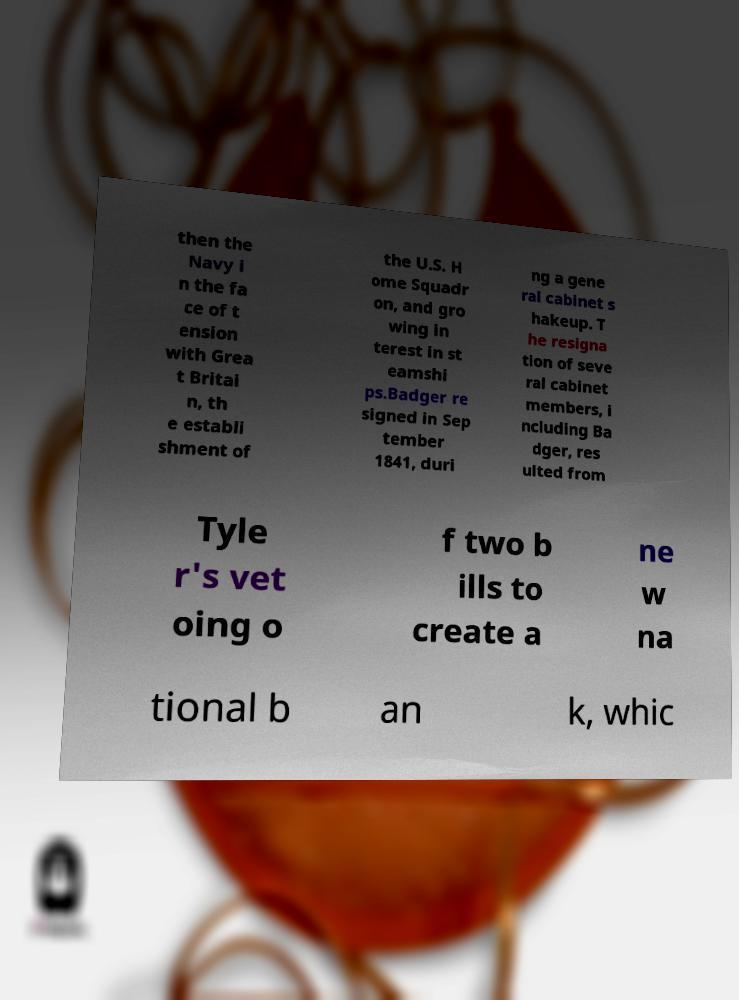Can you read and provide the text displayed in the image?This photo seems to have some interesting text. Can you extract and type it out for me? then the Navy i n the fa ce of t ension with Grea t Britai n, th e establi shment of the U.S. H ome Squadr on, and gro wing in terest in st eamshi ps.Badger re signed in Sep tember 1841, duri ng a gene ral cabinet s hakeup. T he resigna tion of seve ral cabinet members, i ncluding Ba dger, res ulted from Tyle r's vet oing o f two b ills to create a ne w na tional b an k, whic 